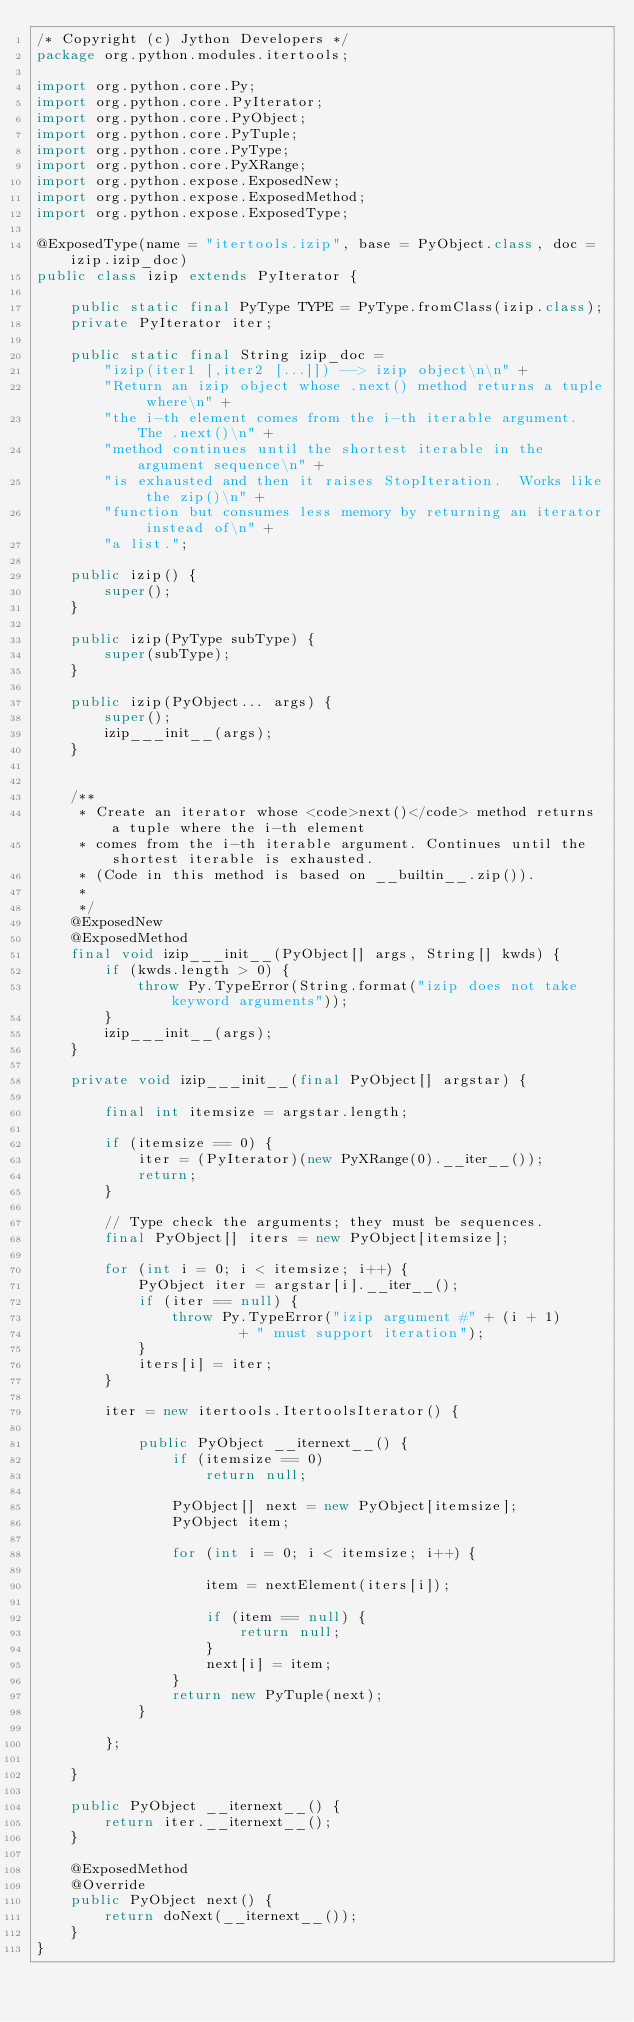Convert code to text. <code><loc_0><loc_0><loc_500><loc_500><_Java_>/* Copyright (c) Jython Developers */
package org.python.modules.itertools;

import org.python.core.Py;
import org.python.core.PyIterator;
import org.python.core.PyObject;
import org.python.core.PyTuple;
import org.python.core.PyType;
import org.python.core.PyXRange;
import org.python.expose.ExposedNew;
import org.python.expose.ExposedMethod;
import org.python.expose.ExposedType;

@ExposedType(name = "itertools.izip", base = PyObject.class, doc = izip.izip_doc)
public class izip extends PyIterator {

    public static final PyType TYPE = PyType.fromClass(izip.class);
    private PyIterator iter;

    public static final String izip_doc =
        "izip(iter1 [,iter2 [...]]) --> izip object\n\n" +
        "Return an izip object whose .next() method returns a tuple where\n" +
        "the i-th element comes from the i-th iterable argument.  The .next()\n" +
        "method continues until the shortest iterable in the argument sequence\n" +
        "is exhausted and then it raises StopIteration.  Works like the zip()\n" +
        "function but consumes less memory by returning an iterator instead of\n" +
        "a list.";

    public izip() {
        super();
    }

    public izip(PyType subType) {
        super(subType);
    }

    public izip(PyObject... args) {
        super();
        izip___init__(args);
    }


    /**
     * Create an iterator whose <code>next()</code> method returns a tuple where the i-th element
     * comes from the i-th iterable argument. Continues until the shortest iterable is exhausted.
     * (Code in this method is based on __builtin__.zip()).
     * 
     */
    @ExposedNew
    @ExposedMethod
    final void izip___init__(PyObject[] args, String[] kwds) {
        if (kwds.length > 0) {
            throw Py.TypeError(String.format("izip does not take keyword arguments"));
        }
        izip___init__(args);
    }

    private void izip___init__(final PyObject[] argstar) {

        final int itemsize = argstar.length;
        
        if (itemsize == 0) {
            iter = (PyIterator)(new PyXRange(0).__iter__());
            return;
        }

        // Type check the arguments; they must be sequences.
        final PyObject[] iters = new PyObject[itemsize];

        for (int i = 0; i < itemsize; i++) {
            PyObject iter = argstar[i].__iter__();
            if (iter == null) {
                throw Py.TypeError("izip argument #" + (i + 1)
                        + " must support iteration");
            }
            iters[i] = iter;
        }

        iter = new itertools.ItertoolsIterator() {

            public PyObject __iternext__() {
                if (itemsize == 0)
                    return null;

                PyObject[] next = new PyObject[itemsize];
                PyObject item;

                for (int i = 0; i < itemsize; i++) {

                    item = nextElement(iters[i]);

                    if (item == null) {
                        return null;
                    }
                    next[i] = item;
                }
                return new PyTuple(next);
            }

        };

    }

    public PyObject __iternext__() {
        return iter.__iternext__();
    }

    @ExposedMethod
    @Override
    public PyObject next() {
        return doNext(__iternext__());
    }
}
</code> 